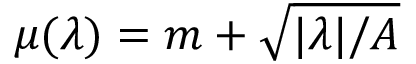Convert formula to latex. <formula><loc_0><loc_0><loc_500><loc_500>\mu ( \lambda ) = m + \sqrt { | \lambda | / A }</formula> 